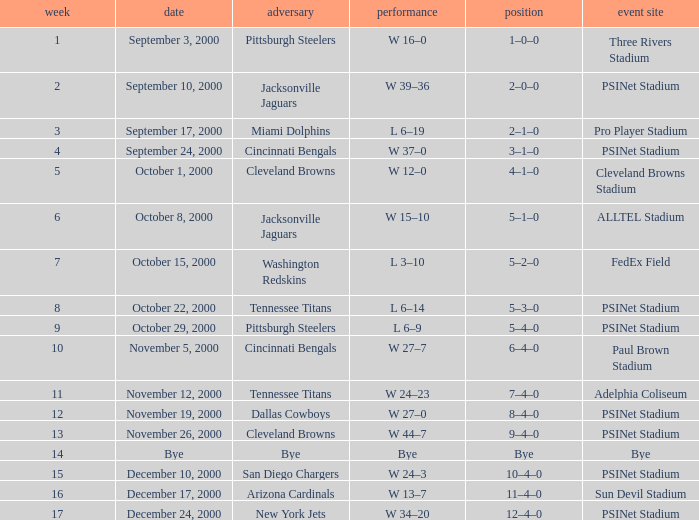What's the record after week 12 with a game site of bye? Bye. 